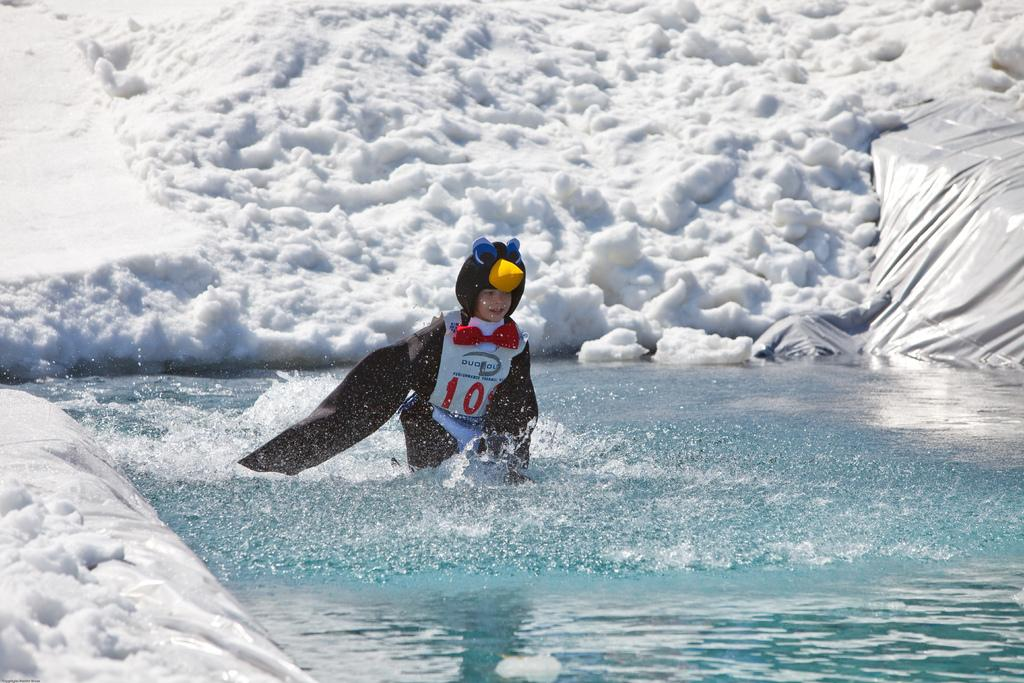What is the main subject of the image? There is a person in the water in the center of the image. What is the condition of the surface at the bottom of the image? There is snow on the surface at the bottom of the image. What can be seen on the right side of the image? There is a cover on the right side of the image. What thought does the person's daughter have while observing the image? There is no information about the person's daughter in the image, so it is impossible to determine their thoughts. How does the person smash the snow in the image? There is no action of smashing snow in the image; the person is simply in the water, and the snow is on the surface at the bottom of the image. 